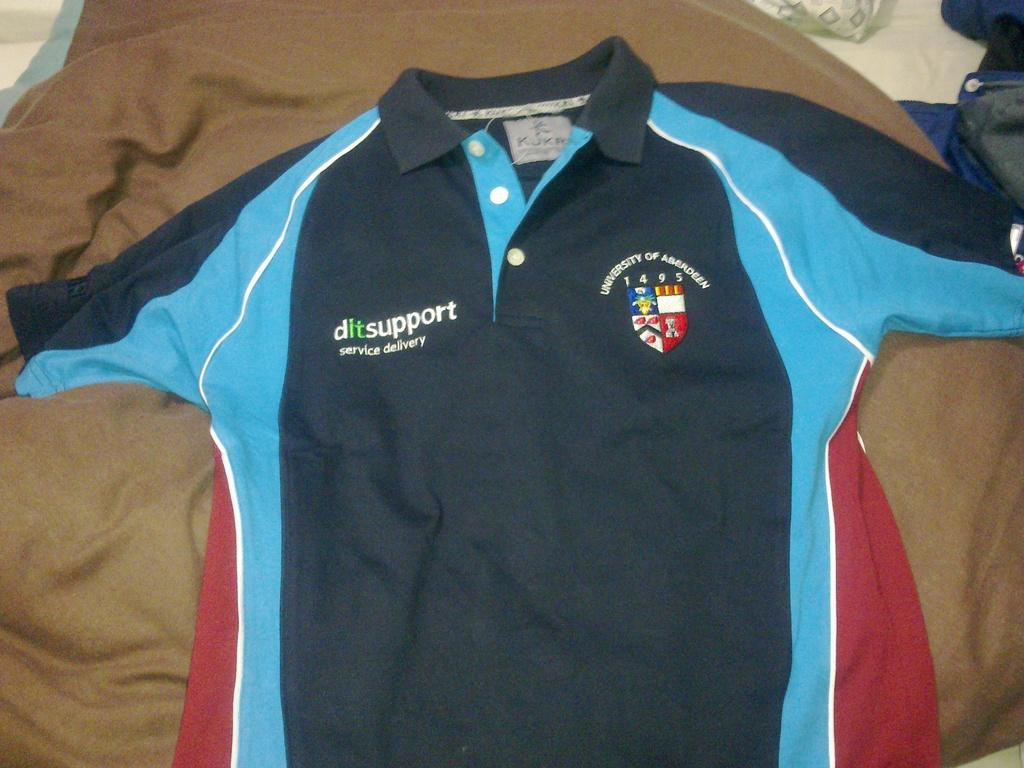<image>
Write a terse but informative summary of the picture. A shirt that says ditsupport service delivery is laid out on a bed. 